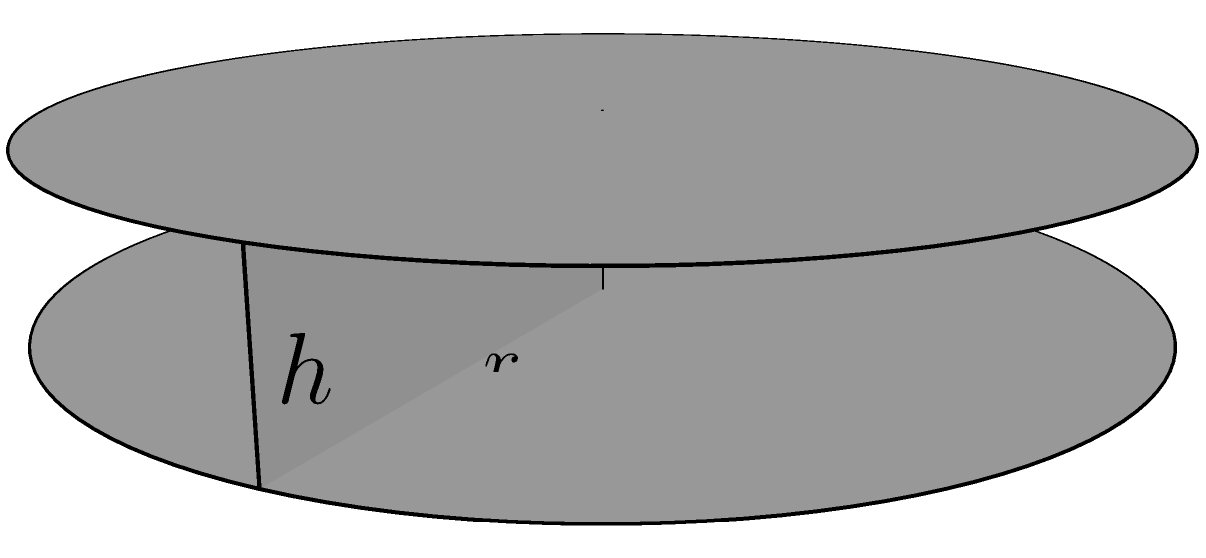Imagine you're setting up your vintage turntable to play your favorite Diana Ross vinyl from the 80s. The turntable platter is cylindrical with a radius of 6 inches and a height of 2 inches. What is the volume of the turntable platter in cubic inches? Let's approach this step-by-step:

1) The volume of a cylinder is given by the formula:

   $$ V = \pi r^2 h $$

   Where:
   $V$ is the volume
   $r$ is the radius of the base
   $h$ is the height of the cylinder

2) We're given:
   Radius ($r$) = 6 inches
   Height ($h$) = 2 inches

3) Let's substitute these values into our formula:

   $$ V = \pi (6^2) (2) $$

4) First, let's calculate $6^2$:
   
   $$ V = \pi (36) (2) $$

5) Now, multiply:

   $$ V = \pi (72) $$

6) $\pi$ is approximately 3.14159, so:

   $$ V \approx 3.14159 (72) \approx 226.19 $$

Therefore, the volume of the turntable platter is approximately 226.19 cubic inches.
Answer: $226.19$ cubic inches 